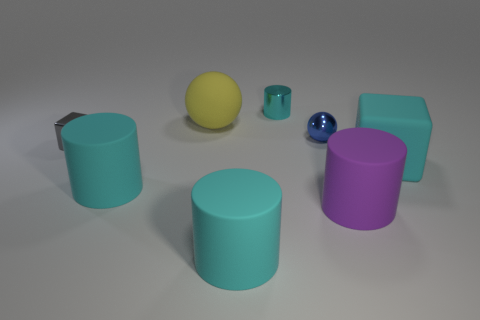Subtract all cyan cylinders. How many were subtracted if there are1cyan cylinders left? 2 Subtract all purple cylinders. How many cylinders are left? 3 Subtract all yellow spheres. How many cyan cylinders are left? 3 Subtract all purple cylinders. How many cylinders are left? 3 Add 1 big cyan blocks. How many objects exist? 9 Subtract 2 balls. How many balls are left? 0 Add 2 metallic cubes. How many metallic cubes exist? 3 Subtract 0 yellow cylinders. How many objects are left? 8 Subtract all cubes. How many objects are left? 6 Subtract all purple cylinders. Subtract all gray spheres. How many cylinders are left? 3 